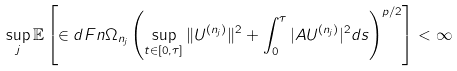<formula> <loc_0><loc_0><loc_500><loc_500>\sup _ { j } \mathbb { E } \left [ \in d F n { \Omega _ { n _ { j } } } \left ( \sup _ { t \in [ 0 , \tau ] } \| U ^ { ( n _ { j } ) } \| ^ { 2 } + \int _ { 0 } ^ { \tau } | A U ^ { ( n _ { j } ) } | ^ { 2 } d s \right ) ^ { p / 2 } \right ] < \infty</formula> 